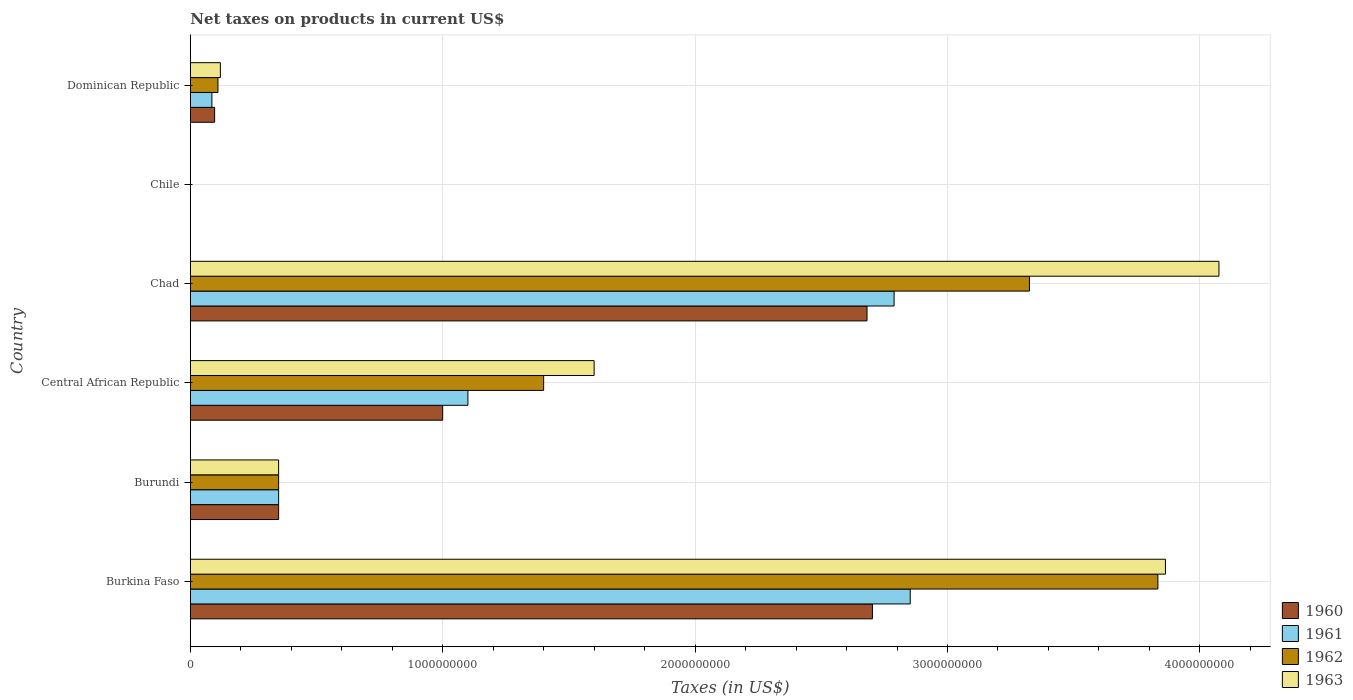How many groups of bars are there?
Keep it short and to the point. 6. Are the number of bars per tick equal to the number of legend labels?
Keep it short and to the point. Yes. How many bars are there on the 1st tick from the top?
Provide a succinct answer. 4. How many bars are there on the 6th tick from the bottom?
Make the answer very short. 4. What is the label of the 3rd group of bars from the top?
Your answer should be compact. Chad. In how many cases, is the number of bars for a given country not equal to the number of legend labels?
Make the answer very short. 0. What is the net taxes on products in 1962 in Chile?
Keep it short and to the point. 2.53e+05. Across all countries, what is the maximum net taxes on products in 1963?
Offer a terse response. 4.08e+09. Across all countries, what is the minimum net taxes on products in 1962?
Make the answer very short. 2.53e+05. In which country was the net taxes on products in 1960 maximum?
Give a very brief answer. Burkina Faso. In which country was the net taxes on products in 1963 minimum?
Offer a terse response. Chile. What is the total net taxes on products in 1962 in the graph?
Offer a very short reply. 9.02e+09. What is the difference between the net taxes on products in 1962 in Burundi and that in Central African Republic?
Your answer should be compact. -1.05e+09. What is the difference between the net taxes on products in 1961 in Chad and the net taxes on products in 1960 in Dominican Republic?
Offer a very short reply. 2.69e+09. What is the average net taxes on products in 1963 per country?
Provide a short and direct response. 1.67e+09. What is the difference between the net taxes on products in 1961 and net taxes on products in 1963 in Burkina Faso?
Ensure brevity in your answer.  -1.01e+09. What is the ratio of the net taxes on products in 1962 in Burundi to that in Central African Republic?
Keep it short and to the point. 0.25. Is the net taxes on products in 1962 in Burkina Faso less than that in Chile?
Offer a terse response. No. What is the difference between the highest and the second highest net taxes on products in 1960?
Make the answer very short. 2.13e+07. What is the difference between the highest and the lowest net taxes on products in 1962?
Offer a terse response. 3.83e+09. Is the sum of the net taxes on products in 1962 in Chad and Dominican Republic greater than the maximum net taxes on products in 1963 across all countries?
Your answer should be compact. No. What does the 1st bar from the top in Chad represents?
Your answer should be very brief. 1963. What does the 1st bar from the bottom in Central African Republic represents?
Provide a succinct answer. 1960. Is it the case that in every country, the sum of the net taxes on products in 1963 and net taxes on products in 1961 is greater than the net taxes on products in 1960?
Give a very brief answer. Yes. How many bars are there?
Make the answer very short. 24. Are all the bars in the graph horizontal?
Your answer should be very brief. Yes. How many countries are there in the graph?
Ensure brevity in your answer.  6. What is the difference between two consecutive major ticks on the X-axis?
Your answer should be very brief. 1.00e+09. Are the values on the major ticks of X-axis written in scientific E-notation?
Offer a very short reply. No. Does the graph contain grids?
Make the answer very short. Yes. Where does the legend appear in the graph?
Offer a terse response. Bottom right. How many legend labels are there?
Provide a succinct answer. 4. What is the title of the graph?
Your answer should be very brief. Net taxes on products in current US$. Does "1991" appear as one of the legend labels in the graph?
Your response must be concise. No. What is the label or title of the X-axis?
Make the answer very short. Taxes (in US$). What is the Taxes (in US$) of 1960 in Burkina Faso?
Your answer should be compact. 2.70e+09. What is the Taxes (in US$) of 1961 in Burkina Faso?
Keep it short and to the point. 2.85e+09. What is the Taxes (in US$) of 1962 in Burkina Faso?
Provide a short and direct response. 3.83e+09. What is the Taxes (in US$) in 1963 in Burkina Faso?
Provide a short and direct response. 3.86e+09. What is the Taxes (in US$) in 1960 in Burundi?
Make the answer very short. 3.50e+08. What is the Taxes (in US$) of 1961 in Burundi?
Provide a short and direct response. 3.50e+08. What is the Taxes (in US$) of 1962 in Burundi?
Your response must be concise. 3.50e+08. What is the Taxes (in US$) of 1963 in Burundi?
Your answer should be very brief. 3.50e+08. What is the Taxes (in US$) of 1960 in Central African Republic?
Provide a short and direct response. 1.00e+09. What is the Taxes (in US$) in 1961 in Central African Republic?
Provide a short and direct response. 1.10e+09. What is the Taxes (in US$) of 1962 in Central African Republic?
Your answer should be compact. 1.40e+09. What is the Taxes (in US$) in 1963 in Central African Republic?
Your response must be concise. 1.60e+09. What is the Taxes (in US$) of 1960 in Chad?
Provide a short and direct response. 2.68e+09. What is the Taxes (in US$) of 1961 in Chad?
Ensure brevity in your answer.  2.79e+09. What is the Taxes (in US$) of 1962 in Chad?
Provide a short and direct response. 3.32e+09. What is the Taxes (in US$) of 1963 in Chad?
Provide a short and direct response. 4.08e+09. What is the Taxes (in US$) in 1960 in Chile?
Provide a succinct answer. 2.02e+05. What is the Taxes (in US$) of 1961 in Chile?
Ensure brevity in your answer.  2.53e+05. What is the Taxes (in US$) in 1962 in Chile?
Offer a very short reply. 2.53e+05. What is the Taxes (in US$) of 1963 in Chile?
Your answer should be very brief. 3.54e+05. What is the Taxes (in US$) of 1960 in Dominican Republic?
Your answer should be very brief. 9.64e+07. What is the Taxes (in US$) of 1961 in Dominican Republic?
Your answer should be very brief. 8.56e+07. What is the Taxes (in US$) in 1962 in Dominican Republic?
Offer a terse response. 1.10e+08. What is the Taxes (in US$) of 1963 in Dominican Republic?
Provide a succinct answer. 1.19e+08. Across all countries, what is the maximum Taxes (in US$) of 1960?
Make the answer very short. 2.70e+09. Across all countries, what is the maximum Taxes (in US$) in 1961?
Provide a short and direct response. 2.85e+09. Across all countries, what is the maximum Taxes (in US$) in 1962?
Offer a very short reply. 3.83e+09. Across all countries, what is the maximum Taxes (in US$) of 1963?
Provide a short and direct response. 4.08e+09. Across all countries, what is the minimum Taxes (in US$) in 1960?
Your answer should be very brief. 2.02e+05. Across all countries, what is the minimum Taxes (in US$) of 1961?
Provide a succinct answer. 2.53e+05. Across all countries, what is the minimum Taxes (in US$) of 1962?
Offer a terse response. 2.53e+05. Across all countries, what is the minimum Taxes (in US$) of 1963?
Keep it short and to the point. 3.54e+05. What is the total Taxes (in US$) in 1960 in the graph?
Offer a very short reply. 6.83e+09. What is the total Taxes (in US$) in 1961 in the graph?
Offer a terse response. 7.18e+09. What is the total Taxes (in US$) in 1962 in the graph?
Provide a succinct answer. 9.02e+09. What is the total Taxes (in US$) of 1963 in the graph?
Your answer should be very brief. 1.00e+1. What is the difference between the Taxes (in US$) of 1960 in Burkina Faso and that in Burundi?
Ensure brevity in your answer.  2.35e+09. What is the difference between the Taxes (in US$) in 1961 in Burkina Faso and that in Burundi?
Keep it short and to the point. 2.50e+09. What is the difference between the Taxes (in US$) of 1962 in Burkina Faso and that in Burundi?
Your response must be concise. 3.48e+09. What is the difference between the Taxes (in US$) in 1963 in Burkina Faso and that in Burundi?
Offer a terse response. 3.51e+09. What is the difference between the Taxes (in US$) of 1960 in Burkina Faso and that in Central African Republic?
Give a very brief answer. 1.70e+09. What is the difference between the Taxes (in US$) in 1961 in Burkina Faso and that in Central African Republic?
Make the answer very short. 1.75e+09. What is the difference between the Taxes (in US$) in 1962 in Burkina Faso and that in Central African Republic?
Your answer should be compact. 2.43e+09. What is the difference between the Taxes (in US$) of 1963 in Burkina Faso and that in Central African Republic?
Keep it short and to the point. 2.26e+09. What is the difference between the Taxes (in US$) of 1960 in Burkina Faso and that in Chad?
Give a very brief answer. 2.13e+07. What is the difference between the Taxes (in US$) in 1961 in Burkina Faso and that in Chad?
Give a very brief answer. 6.39e+07. What is the difference between the Taxes (in US$) in 1962 in Burkina Faso and that in Chad?
Ensure brevity in your answer.  5.09e+08. What is the difference between the Taxes (in US$) of 1963 in Burkina Faso and that in Chad?
Offer a terse response. -2.12e+08. What is the difference between the Taxes (in US$) of 1960 in Burkina Faso and that in Chile?
Your answer should be very brief. 2.70e+09. What is the difference between the Taxes (in US$) of 1961 in Burkina Faso and that in Chile?
Provide a short and direct response. 2.85e+09. What is the difference between the Taxes (in US$) of 1962 in Burkina Faso and that in Chile?
Your response must be concise. 3.83e+09. What is the difference between the Taxes (in US$) in 1963 in Burkina Faso and that in Chile?
Offer a terse response. 3.86e+09. What is the difference between the Taxes (in US$) of 1960 in Burkina Faso and that in Dominican Republic?
Offer a terse response. 2.61e+09. What is the difference between the Taxes (in US$) of 1961 in Burkina Faso and that in Dominican Republic?
Your response must be concise. 2.77e+09. What is the difference between the Taxes (in US$) in 1962 in Burkina Faso and that in Dominican Republic?
Your answer should be compact. 3.72e+09. What is the difference between the Taxes (in US$) of 1963 in Burkina Faso and that in Dominican Republic?
Your answer should be very brief. 3.74e+09. What is the difference between the Taxes (in US$) of 1960 in Burundi and that in Central African Republic?
Your answer should be compact. -6.50e+08. What is the difference between the Taxes (in US$) of 1961 in Burundi and that in Central African Republic?
Offer a terse response. -7.50e+08. What is the difference between the Taxes (in US$) in 1962 in Burundi and that in Central African Republic?
Offer a terse response. -1.05e+09. What is the difference between the Taxes (in US$) of 1963 in Burundi and that in Central African Republic?
Offer a terse response. -1.25e+09. What is the difference between the Taxes (in US$) in 1960 in Burundi and that in Chad?
Ensure brevity in your answer.  -2.33e+09. What is the difference between the Taxes (in US$) of 1961 in Burundi and that in Chad?
Your answer should be very brief. -2.44e+09. What is the difference between the Taxes (in US$) in 1962 in Burundi and that in Chad?
Give a very brief answer. -2.97e+09. What is the difference between the Taxes (in US$) in 1963 in Burundi and that in Chad?
Provide a short and direct response. -3.73e+09. What is the difference between the Taxes (in US$) of 1960 in Burundi and that in Chile?
Provide a short and direct response. 3.50e+08. What is the difference between the Taxes (in US$) in 1961 in Burundi and that in Chile?
Offer a very short reply. 3.50e+08. What is the difference between the Taxes (in US$) of 1962 in Burundi and that in Chile?
Your answer should be compact. 3.50e+08. What is the difference between the Taxes (in US$) of 1963 in Burundi and that in Chile?
Your answer should be very brief. 3.50e+08. What is the difference between the Taxes (in US$) in 1960 in Burundi and that in Dominican Republic?
Your answer should be compact. 2.54e+08. What is the difference between the Taxes (in US$) of 1961 in Burundi and that in Dominican Republic?
Your answer should be compact. 2.64e+08. What is the difference between the Taxes (in US$) in 1962 in Burundi and that in Dominican Republic?
Keep it short and to the point. 2.40e+08. What is the difference between the Taxes (in US$) in 1963 in Burundi and that in Dominican Republic?
Offer a terse response. 2.31e+08. What is the difference between the Taxes (in US$) of 1960 in Central African Republic and that in Chad?
Your answer should be very brief. -1.68e+09. What is the difference between the Taxes (in US$) of 1961 in Central African Republic and that in Chad?
Give a very brief answer. -1.69e+09. What is the difference between the Taxes (in US$) of 1962 in Central African Republic and that in Chad?
Ensure brevity in your answer.  -1.92e+09. What is the difference between the Taxes (in US$) in 1963 in Central African Republic and that in Chad?
Keep it short and to the point. -2.48e+09. What is the difference between the Taxes (in US$) in 1960 in Central African Republic and that in Chile?
Your response must be concise. 1.00e+09. What is the difference between the Taxes (in US$) in 1961 in Central African Republic and that in Chile?
Your answer should be compact. 1.10e+09. What is the difference between the Taxes (in US$) in 1962 in Central African Republic and that in Chile?
Provide a succinct answer. 1.40e+09. What is the difference between the Taxes (in US$) in 1963 in Central African Republic and that in Chile?
Your answer should be very brief. 1.60e+09. What is the difference between the Taxes (in US$) in 1960 in Central African Republic and that in Dominican Republic?
Provide a succinct answer. 9.04e+08. What is the difference between the Taxes (in US$) of 1961 in Central African Republic and that in Dominican Republic?
Provide a short and direct response. 1.01e+09. What is the difference between the Taxes (in US$) in 1962 in Central African Republic and that in Dominican Republic?
Keep it short and to the point. 1.29e+09. What is the difference between the Taxes (in US$) in 1963 in Central African Republic and that in Dominican Republic?
Ensure brevity in your answer.  1.48e+09. What is the difference between the Taxes (in US$) of 1960 in Chad and that in Chile?
Keep it short and to the point. 2.68e+09. What is the difference between the Taxes (in US$) of 1961 in Chad and that in Chile?
Your answer should be compact. 2.79e+09. What is the difference between the Taxes (in US$) in 1962 in Chad and that in Chile?
Your response must be concise. 3.32e+09. What is the difference between the Taxes (in US$) of 1963 in Chad and that in Chile?
Provide a short and direct response. 4.08e+09. What is the difference between the Taxes (in US$) in 1960 in Chad and that in Dominican Republic?
Offer a very short reply. 2.58e+09. What is the difference between the Taxes (in US$) in 1961 in Chad and that in Dominican Republic?
Offer a very short reply. 2.70e+09. What is the difference between the Taxes (in US$) of 1962 in Chad and that in Dominican Republic?
Provide a succinct answer. 3.22e+09. What is the difference between the Taxes (in US$) of 1963 in Chad and that in Dominican Republic?
Your answer should be compact. 3.96e+09. What is the difference between the Taxes (in US$) of 1960 in Chile and that in Dominican Republic?
Keep it short and to the point. -9.62e+07. What is the difference between the Taxes (in US$) in 1961 in Chile and that in Dominican Republic?
Provide a succinct answer. -8.53e+07. What is the difference between the Taxes (in US$) in 1962 in Chile and that in Dominican Republic?
Your answer should be very brief. -1.09e+08. What is the difference between the Taxes (in US$) of 1963 in Chile and that in Dominican Republic?
Offer a terse response. -1.19e+08. What is the difference between the Taxes (in US$) of 1960 in Burkina Faso and the Taxes (in US$) of 1961 in Burundi?
Provide a succinct answer. 2.35e+09. What is the difference between the Taxes (in US$) of 1960 in Burkina Faso and the Taxes (in US$) of 1962 in Burundi?
Provide a succinct answer. 2.35e+09. What is the difference between the Taxes (in US$) in 1960 in Burkina Faso and the Taxes (in US$) in 1963 in Burundi?
Keep it short and to the point. 2.35e+09. What is the difference between the Taxes (in US$) of 1961 in Burkina Faso and the Taxes (in US$) of 1962 in Burundi?
Offer a terse response. 2.50e+09. What is the difference between the Taxes (in US$) in 1961 in Burkina Faso and the Taxes (in US$) in 1963 in Burundi?
Your answer should be very brief. 2.50e+09. What is the difference between the Taxes (in US$) in 1962 in Burkina Faso and the Taxes (in US$) in 1963 in Burundi?
Ensure brevity in your answer.  3.48e+09. What is the difference between the Taxes (in US$) in 1960 in Burkina Faso and the Taxes (in US$) in 1961 in Central African Republic?
Your response must be concise. 1.60e+09. What is the difference between the Taxes (in US$) in 1960 in Burkina Faso and the Taxes (in US$) in 1962 in Central African Republic?
Your answer should be compact. 1.30e+09. What is the difference between the Taxes (in US$) in 1960 in Burkina Faso and the Taxes (in US$) in 1963 in Central African Republic?
Your response must be concise. 1.10e+09. What is the difference between the Taxes (in US$) of 1961 in Burkina Faso and the Taxes (in US$) of 1962 in Central African Republic?
Your response must be concise. 1.45e+09. What is the difference between the Taxes (in US$) of 1961 in Burkina Faso and the Taxes (in US$) of 1963 in Central African Republic?
Ensure brevity in your answer.  1.25e+09. What is the difference between the Taxes (in US$) of 1962 in Burkina Faso and the Taxes (in US$) of 1963 in Central African Republic?
Make the answer very short. 2.23e+09. What is the difference between the Taxes (in US$) of 1960 in Burkina Faso and the Taxes (in US$) of 1961 in Chad?
Your response must be concise. -8.59e+07. What is the difference between the Taxes (in US$) of 1960 in Burkina Faso and the Taxes (in US$) of 1962 in Chad?
Your response must be concise. -6.22e+08. What is the difference between the Taxes (in US$) of 1960 in Burkina Faso and the Taxes (in US$) of 1963 in Chad?
Keep it short and to the point. -1.37e+09. What is the difference between the Taxes (in US$) of 1961 in Burkina Faso and the Taxes (in US$) of 1962 in Chad?
Keep it short and to the point. -4.72e+08. What is the difference between the Taxes (in US$) in 1961 in Burkina Faso and the Taxes (in US$) in 1963 in Chad?
Make the answer very short. -1.22e+09. What is the difference between the Taxes (in US$) in 1962 in Burkina Faso and the Taxes (in US$) in 1963 in Chad?
Keep it short and to the point. -2.42e+08. What is the difference between the Taxes (in US$) of 1960 in Burkina Faso and the Taxes (in US$) of 1961 in Chile?
Your answer should be compact. 2.70e+09. What is the difference between the Taxes (in US$) of 1960 in Burkina Faso and the Taxes (in US$) of 1962 in Chile?
Provide a succinct answer. 2.70e+09. What is the difference between the Taxes (in US$) in 1960 in Burkina Faso and the Taxes (in US$) in 1963 in Chile?
Keep it short and to the point. 2.70e+09. What is the difference between the Taxes (in US$) of 1961 in Burkina Faso and the Taxes (in US$) of 1962 in Chile?
Provide a succinct answer. 2.85e+09. What is the difference between the Taxes (in US$) in 1961 in Burkina Faso and the Taxes (in US$) in 1963 in Chile?
Give a very brief answer. 2.85e+09. What is the difference between the Taxes (in US$) in 1962 in Burkina Faso and the Taxes (in US$) in 1963 in Chile?
Your response must be concise. 3.83e+09. What is the difference between the Taxes (in US$) in 1960 in Burkina Faso and the Taxes (in US$) in 1961 in Dominican Republic?
Ensure brevity in your answer.  2.62e+09. What is the difference between the Taxes (in US$) in 1960 in Burkina Faso and the Taxes (in US$) in 1962 in Dominican Republic?
Keep it short and to the point. 2.59e+09. What is the difference between the Taxes (in US$) of 1960 in Burkina Faso and the Taxes (in US$) of 1963 in Dominican Republic?
Your answer should be compact. 2.58e+09. What is the difference between the Taxes (in US$) of 1961 in Burkina Faso and the Taxes (in US$) of 1962 in Dominican Republic?
Offer a very short reply. 2.74e+09. What is the difference between the Taxes (in US$) of 1961 in Burkina Faso and the Taxes (in US$) of 1963 in Dominican Republic?
Your answer should be compact. 2.73e+09. What is the difference between the Taxes (in US$) in 1962 in Burkina Faso and the Taxes (in US$) in 1963 in Dominican Republic?
Provide a short and direct response. 3.71e+09. What is the difference between the Taxes (in US$) of 1960 in Burundi and the Taxes (in US$) of 1961 in Central African Republic?
Make the answer very short. -7.50e+08. What is the difference between the Taxes (in US$) in 1960 in Burundi and the Taxes (in US$) in 1962 in Central African Republic?
Ensure brevity in your answer.  -1.05e+09. What is the difference between the Taxes (in US$) of 1960 in Burundi and the Taxes (in US$) of 1963 in Central African Republic?
Your response must be concise. -1.25e+09. What is the difference between the Taxes (in US$) of 1961 in Burundi and the Taxes (in US$) of 1962 in Central African Republic?
Offer a very short reply. -1.05e+09. What is the difference between the Taxes (in US$) in 1961 in Burundi and the Taxes (in US$) in 1963 in Central African Republic?
Your answer should be very brief. -1.25e+09. What is the difference between the Taxes (in US$) in 1962 in Burundi and the Taxes (in US$) in 1963 in Central African Republic?
Your answer should be very brief. -1.25e+09. What is the difference between the Taxes (in US$) of 1960 in Burundi and the Taxes (in US$) of 1961 in Chad?
Give a very brief answer. -2.44e+09. What is the difference between the Taxes (in US$) in 1960 in Burundi and the Taxes (in US$) in 1962 in Chad?
Offer a very short reply. -2.97e+09. What is the difference between the Taxes (in US$) of 1960 in Burundi and the Taxes (in US$) of 1963 in Chad?
Make the answer very short. -3.73e+09. What is the difference between the Taxes (in US$) of 1961 in Burundi and the Taxes (in US$) of 1962 in Chad?
Ensure brevity in your answer.  -2.97e+09. What is the difference between the Taxes (in US$) of 1961 in Burundi and the Taxes (in US$) of 1963 in Chad?
Keep it short and to the point. -3.73e+09. What is the difference between the Taxes (in US$) in 1962 in Burundi and the Taxes (in US$) in 1963 in Chad?
Offer a terse response. -3.73e+09. What is the difference between the Taxes (in US$) in 1960 in Burundi and the Taxes (in US$) in 1961 in Chile?
Your answer should be very brief. 3.50e+08. What is the difference between the Taxes (in US$) of 1960 in Burundi and the Taxes (in US$) of 1962 in Chile?
Ensure brevity in your answer.  3.50e+08. What is the difference between the Taxes (in US$) in 1960 in Burundi and the Taxes (in US$) in 1963 in Chile?
Give a very brief answer. 3.50e+08. What is the difference between the Taxes (in US$) of 1961 in Burundi and the Taxes (in US$) of 1962 in Chile?
Offer a terse response. 3.50e+08. What is the difference between the Taxes (in US$) of 1961 in Burundi and the Taxes (in US$) of 1963 in Chile?
Offer a terse response. 3.50e+08. What is the difference between the Taxes (in US$) of 1962 in Burundi and the Taxes (in US$) of 1963 in Chile?
Give a very brief answer. 3.50e+08. What is the difference between the Taxes (in US$) in 1960 in Burundi and the Taxes (in US$) in 1961 in Dominican Republic?
Offer a very short reply. 2.64e+08. What is the difference between the Taxes (in US$) in 1960 in Burundi and the Taxes (in US$) in 1962 in Dominican Republic?
Keep it short and to the point. 2.40e+08. What is the difference between the Taxes (in US$) in 1960 in Burundi and the Taxes (in US$) in 1963 in Dominican Republic?
Provide a succinct answer. 2.31e+08. What is the difference between the Taxes (in US$) in 1961 in Burundi and the Taxes (in US$) in 1962 in Dominican Republic?
Offer a very short reply. 2.40e+08. What is the difference between the Taxes (in US$) in 1961 in Burundi and the Taxes (in US$) in 1963 in Dominican Republic?
Ensure brevity in your answer.  2.31e+08. What is the difference between the Taxes (in US$) of 1962 in Burundi and the Taxes (in US$) of 1963 in Dominican Republic?
Provide a succinct answer. 2.31e+08. What is the difference between the Taxes (in US$) in 1960 in Central African Republic and the Taxes (in US$) in 1961 in Chad?
Your answer should be compact. -1.79e+09. What is the difference between the Taxes (in US$) of 1960 in Central African Republic and the Taxes (in US$) of 1962 in Chad?
Provide a short and direct response. -2.32e+09. What is the difference between the Taxes (in US$) of 1960 in Central African Republic and the Taxes (in US$) of 1963 in Chad?
Offer a terse response. -3.08e+09. What is the difference between the Taxes (in US$) of 1961 in Central African Republic and the Taxes (in US$) of 1962 in Chad?
Give a very brief answer. -2.22e+09. What is the difference between the Taxes (in US$) of 1961 in Central African Republic and the Taxes (in US$) of 1963 in Chad?
Provide a short and direct response. -2.98e+09. What is the difference between the Taxes (in US$) in 1962 in Central African Republic and the Taxes (in US$) in 1963 in Chad?
Your answer should be compact. -2.68e+09. What is the difference between the Taxes (in US$) of 1960 in Central African Republic and the Taxes (in US$) of 1961 in Chile?
Your response must be concise. 1.00e+09. What is the difference between the Taxes (in US$) in 1960 in Central African Republic and the Taxes (in US$) in 1962 in Chile?
Offer a very short reply. 1.00e+09. What is the difference between the Taxes (in US$) in 1960 in Central African Republic and the Taxes (in US$) in 1963 in Chile?
Keep it short and to the point. 1.00e+09. What is the difference between the Taxes (in US$) in 1961 in Central African Republic and the Taxes (in US$) in 1962 in Chile?
Keep it short and to the point. 1.10e+09. What is the difference between the Taxes (in US$) in 1961 in Central African Republic and the Taxes (in US$) in 1963 in Chile?
Give a very brief answer. 1.10e+09. What is the difference between the Taxes (in US$) in 1962 in Central African Republic and the Taxes (in US$) in 1963 in Chile?
Keep it short and to the point. 1.40e+09. What is the difference between the Taxes (in US$) of 1960 in Central African Republic and the Taxes (in US$) of 1961 in Dominican Republic?
Your answer should be very brief. 9.14e+08. What is the difference between the Taxes (in US$) of 1960 in Central African Republic and the Taxes (in US$) of 1962 in Dominican Republic?
Your answer should be compact. 8.90e+08. What is the difference between the Taxes (in US$) of 1960 in Central African Republic and the Taxes (in US$) of 1963 in Dominican Republic?
Make the answer very short. 8.81e+08. What is the difference between the Taxes (in US$) in 1961 in Central African Republic and the Taxes (in US$) in 1962 in Dominican Republic?
Your answer should be compact. 9.90e+08. What is the difference between the Taxes (in US$) in 1961 in Central African Republic and the Taxes (in US$) in 1963 in Dominican Republic?
Provide a succinct answer. 9.81e+08. What is the difference between the Taxes (in US$) of 1962 in Central African Republic and the Taxes (in US$) of 1963 in Dominican Republic?
Keep it short and to the point. 1.28e+09. What is the difference between the Taxes (in US$) of 1960 in Chad and the Taxes (in US$) of 1961 in Chile?
Offer a very short reply. 2.68e+09. What is the difference between the Taxes (in US$) in 1960 in Chad and the Taxes (in US$) in 1962 in Chile?
Offer a terse response. 2.68e+09. What is the difference between the Taxes (in US$) in 1960 in Chad and the Taxes (in US$) in 1963 in Chile?
Keep it short and to the point. 2.68e+09. What is the difference between the Taxes (in US$) in 1961 in Chad and the Taxes (in US$) in 1962 in Chile?
Your response must be concise. 2.79e+09. What is the difference between the Taxes (in US$) of 1961 in Chad and the Taxes (in US$) of 1963 in Chile?
Offer a terse response. 2.79e+09. What is the difference between the Taxes (in US$) in 1962 in Chad and the Taxes (in US$) in 1963 in Chile?
Provide a succinct answer. 3.32e+09. What is the difference between the Taxes (in US$) in 1960 in Chad and the Taxes (in US$) in 1961 in Dominican Republic?
Provide a succinct answer. 2.60e+09. What is the difference between the Taxes (in US$) of 1960 in Chad and the Taxes (in US$) of 1962 in Dominican Republic?
Make the answer very short. 2.57e+09. What is the difference between the Taxes (in US$) of 1960 in Chad and the Taxes (in US$) of 1963 in Dominican Republic?
Give a very brief answer. 2.56e+09. What is the difference between the Taxes (in US$) in 1961 in Chad and the Taxes (in US$) in 1962 in Dominican Republic?
Make the answer very short. 2.68e+09. What is the difference between the Taxes (in US$) of 1961 in Chad and the Taxes (in US$) of 1963 in Dominican Republic?
Provide a succinct answer. 2.67e+09. What is the difference between the Taxes (in US$) in 1962 in Chad and the Taxes (in US$) in 1963 in Dominican Republic?
Ensure brevity in your answer.  3.21e+09. What is the difference between the Taxes (in US$) of 1960 in Chile and the Taxes (in US$) of 1961 in Dominican Republic?
Ensure brevity in your answer.  -8.54e+07. What is the difference between the Taxes (in US$) of 1960 in Chile and the Taxes (in US$) of 1962 in Dominican Republic?
Give a very brief answer. -1.09e+08. What is the difference between the Taxes (in US$) in 1960 in Chile and the Taxes (in US$) in 1963 in Dominican Republic?
Your response must be concise. -1.19e+08. What is the difference between the Taxes (in US$) in 1961 in Chile and the Taxes (in US$) in 1962 in Dominican Republic?
Your answer should be very brief. -1.09e+08. What is the difference between the Taxes (in US$) in 1961 in Chile and the Taxes (in US$) in 1963 in Dominican Republic?
Offer a terse response. -1.19e+08. What is the difference between the Taxes (in US$) in 1962 in Chile and the Taxes (in US$) in 1963 in Dominican Republic?
Make the answer very short. -1.19e+08. What is the average Taxes (in US$) of 1960 per country?
Ensure brevity in your answer.  1.14e+09. What is the average Taxes (in US$) in 1961 per country?
Give a very brief answer. 1.20e+09. What is the average Taxes (in US$) in 1962 per country?
Offer a very short reply. 1.50e+09. What is the average Taxes (in US$) in 1963 per country?
Provide a succinct answer. 1.67e+09. What is the difference between the Taxes (in US$) of 1960 and Taxes (in US$) of 1961 in Burkina Faso?
Offer a very short reply. -1.50e+08. What is the difference between the Taxes (in US$) of 1960 and Taxes (in US$) of 1962 in Burkina Faso?
Your answer should be compact. -1.13e+09. What is the difference between the Taxes (in US$) of 1960 and Taxes (in US$) of 1963 in Burkina Faso?
Offer a terse response. -1.16e+09. What is the difference between the Taxes (in US$) of 1961 and Taxes (in US$) of 1962 in Burkina Faso?
Keep it short and to the point. -9.81e+08. What is the difference between the Taxes (in US$) of 1961 and Taxes (in US$) of 1963 in Burkina Faso?
Offer a terse response. -1.01e+09. What is the difference between the Taxes (in US$) in 1962 and Taxes (in US$) in 1963 in Burkina Faso?
Your answer should be compact. -3.00e+07. What is the difference between the Taxes (in US$) of 1960 and Taxes (in US$) of 1961 in Burundi?
Give a very brief answer. 0. What is the difference between the Taxes (in US$) of 1960 and Taxes (in US$) of 1962 in Burundi?
Your answer should be very brief. 0. What is the difference between the Taxes (in US$) of 1960 and Taxes (in US$) of 1963 in Burundi?
Your answer should be very brief. 0. What is the difference between the Taxes (in US$) in 1962 and Taxes (in US$) in 1963 in Burundi?
Give a very brief answer. 0. What is the difference between the Taxes (in US$) in 1960 and Taxes (in US$) in 1961 in Central African Republic?
Give a very brief answer. -1.00e+08. What is the difference between the Taxes (in US$) in 1960 and Taxes (in US$) in 1962 in Central African Republic?
Provide a succinct answer. -4.00e+08. What is the difference between the Taxes (in US$) in 1960 and Taxes (in US$) in 1963 in Central African Republic?
Your answer should be compact. -6.00e+08. What is the difference between the Taxes (in US$) of 1961 and Taxes (in US$) of 1962 in Central African Republic?
Provide a short and direct response. -3.00e+08. What is the difference between the Taxes (in US$) in 1961 and Taxes (in US$) in 1963 in Central African Republic?
Offer a very short reply. -5.00e+08. What is the difference between the Taxes (in US$) of 1962 and Taxes (in US$) of 1963 in Central African Republic?
Your response must be concise. -2.00e+08. What is the difference between the Taxes (in US$) in 1960 and Taxes (in US$) in 1961 in Chad?
Offer a very short reply. -1.07e+08. What is the difference between the Taxes (in US$) in 1960 and Taxes (in US$) in 1962 in Chad?
Make the answer very short. -6.44e+08. What is the difference between the Taxes (in US$) in 1960 and Taxes (in US$) in 1963 in Chad?
Your answer should be very brief. -1.39e+09. What is the difference between the Taxes (in US$) in 1961 and Taxes (in US$) in 1962 in Chad?
Your answer should be very brief. -5.36e+08. What is the difference between the Taxes (in US$) in 1961 and Taxes (in US$) in 1963 in Chad?
Provide a short and direct response. -1.29e+09. What is the difference between the Taxes (in US$) of 1962 and Taxes (in US$) of 1963 in Chad?
Keep it short and to the point. -7.51e+08. What is the difference between the Taxes (in US$) of 1960 and Taxes (in US$) of 1961 in Chile?
Offer a terse response. -5.06e+04. What is the difference between the Taxes (in US$) in 1960 and Taxes (in US$) in 1962 in Chile?
Keep it short and to the point. -5.06e+04. What is the difference between the Taxes (in US$) of 1960 and Taxes (in US$) of 1963 in Chile?
Your answer should be very brief. -1.52e+05. What is the difference between the Taxes (in US$) in 1961 and Taxes (in US$) in 1962 in Chile?
Your answer should be compact. 0. What is the difference between the Taxes (in US$) in 1961 and Taxes (in US$) in 1963 in Chile?
Your answer should be very brief. -1.01e+05. What is the difference between the Taxes (in US$) of 1962 and Taxes (in US$) of 1963 in Chile?
Your response must be concise. -1.01e+05. What is the difference between the Taxes (in US$) in 1960 and Taxes (in US$) in 1961 in Dominican Republic?
Keep it short and to the point. 1.08e+07. What is the difference between the Taxes (in US$) in 1960 and Taxes (in US$) in 1962 in Dominican Republic?
Your answer should be very brief. -1.32e+07. What is the difference between the Taxes (in US$) of 1960 and Taxes (in US$) of 1963 in Dominican Republic?
Provide a short and direct response. -2.28e+07. What is the difference between the Taxes (in US$) of 1961 and Taxes (in US$) of 1962 in Dominican Republic?
Ensure brevity in your answer.  -2.40e+07. What is the difference between the Taxes (in US$) of 1961 and Taxes (in US$) of 1963 in Dominican Republic?
Your answer should be compact. -3.36e+07. What is the difference between the Taxes (in US$) of 1962 and Taxes (in US$) of 1963 in Dominican Republic?
Your response must be concise. -9.60e+06. What is the ratio of the Taxes (in US$) in 1960 in Burkina Faso to that in Burundi?
Provide a short and direct response. 7.72. What is the ratio of the Taxes (in US$) in 1961 in Burkina Faso to that in Burundi?
Keep it short and to the point. 8.15. What is the ratio of the Taxes (in US$) in 1962 in Burkina Faso to that in Burundi?
Offer a terse response. 10.95. What is the ratio of the Taxes (in US$) of 1963 in Burkina Faso to that in Burundi?
Offer a terse response. 11.04. What is the ratio of the Taxes (in US$) of 1960 in Burkina Faso to that in Central African Republic?
Ensure brevity in your answer.  2.7. What is the ratio of the Taxes (in US$) in 1961 in Burkina Faso to that in Central African Republic?
Ensure brevity in your answer.  2.59. What is the ratio of the Taxes (in US$) of 1962 in Burkina Faso to that in Central African Republic?
Provide a short and direct response. 2.74. What is the ratio of the Taxes (in US$) in 1963 in Burkina Faso to that in Central African Republic?
Provide a short and direct response. 2.41. What is the ratio of the Taxes (in US$) in 1960 in Burkina Faso to that in Chad?
Your answer should be compact. 1.01. What is the ratio of the Taxes (in US$) in 1961 in Burkina Faso to that in Chad?
Make the answer very short. 1.02. What is the ratio of the Taxes (in US$) of 1962 in Burkina Faso to that in Chad?
Ensure brevity in your answer.  1.15. What is the ratio of the Taxes (in US$) of 1963 in Burkina Faso to that in Chad?
Offer a terse response. 0.95. What is the ratio of the Taxes (in US$) of 1960 in Burkina Faso to that in Chile?
Offer a very short reply. 1.33e+04. What is the ratio of the Taxes (in US$) of 1961 in Burkina Faso to that in Chile?
Your answer should be very brief. 1.13e+04. What is the ratio of the Taxes (in US$) of 1962 in Burkina Faso to that in Chile?
Make the answer very short. 1.51e+04. What is the ratio of the Taxes (in US$) of 1963 in Burkina Faso to that in Chile?
Provide a short and direct response. 1.09e+04. What is the ratio of the Taxes (in US$) in 1960 in Burkina Faso to that in Dominican Republic?
Give a very brief answer. 28.04. What is the ratio of the Taxes (in US$) in 1961 in Burkina Faso to that in Dominican Republic?
Make the answer very short. 33.32. What is the ratio of the Taxes (in US$) in 1962 in Burkina Faso to that in Dominican Republic?
Your response must be concise. 34.98. What is the ratio of the Taxes (in US$) of 1963 in Burkina Faso to that in Dominican Republic?
Offer a terse response. 32.41. What is the ratio of the Taxes (in US$) in 1960 in Burundi to that in Central African Republic?
Offer a very short reply. 0.35. What is the ratio of the Taxes (in US$) in 1961 in Burundi to that in Central African Republic?
Keep it short and to the point. 0.32. What is the ratio of the Taxes (in US$) in 1962 in Burundi to that in Central African Republic?
Your response must be concise. 0.25. What is the ratio of the Taxes (in US$) in 1963 in Burundi to that in Central African Republic?
Your answer should be compact. 0.22. What is the ratio of the Taxes (in US$) of 1960 in Burundi to that in Chad?
Your response must be concise. 0.13. What is the ratio of the Taxes (in US$) in 1961 in Burundi to that in Chad?
Provide a succinct answer. 0.13. What is the ratio of the Taxes (in US$) of 1962 in Burundi to that in Chad?
Offer a very short reply. 0.11. What is the ratio of the Taxes (in US$) of 1963 in Burundi to that in Chad?
Offer a terse response. 0.09. What is the ratio of the Taxes (in US$) in 1960 in Burundi to that in Chile?
Provide a succinct answer. 1728.4. What is the ratio of the Taxes (in US$) of 1961 in Burundi to that in Chile?
Provide a short and direct response. 1382.85. What is the ratio of the Taxes (in US$) in 1962 in Burundi to that in Chile?
Offer a terse response. 1382.85. What is the ratio of the Taxes (in US$) of 1963 in Burundi to that in Chile?
Provide a short and direct response. 987.58. What is the ratio of the Taxes (in US$) in 1960 in Burundi to that in Dominican Republic?
Offer a very short reply. 3.63. What is the ratio of the Taxes (in US$) of 1961 in Burundi to that in Dominican Republic?
Your answer should be compact. 4.09. What is the ratio of the Taxes (in US$) of 1962 in Burundi to that in Dominican Republic?
Make the answer very short. 3.19. What is the ratio of the Taxes (in US$) of 1963 in Burundi to that in Dominican Republic?
Provide a short and direct response. 2.94. What is the ratio of the Taxes (in US$) in 1960 in Central African Republic to that in Chad?
Provide a short and direct response. 0.37. What is the ratio of the Taxes (in US$) of 1961 in Central African Republic to that in Chad?
Provide a short and direct response. 0.39. What is the ratio of the Taxes (in US$) in 1962 in Central African Republic to that in Chad?
Offer a terse response. 0.42. What is the ratio of the Taxes (in US$) in 1963 in Central African Republic to that in Chad?
Make the answer very short. 0.39. What is the ratio of the Taxes (in US$) of 1960 in Central African Republic to that in Chile?
Your answer should be very brief. 4938.27. What is the ratio of the Taxes (in US$) of 1961 in Central African Republic to that in Chile?
Offer a very short reply. 4346.11. What is the ratio of the Taxes (in US$) of 1962 in Central African Republic to that in Chile?
Your answer should be compact. 5531.41. What is the ratio of the Taxes (in US$) of 1963 in Central African Republic to that in Chile?
Provide a short and direct response. 4514.67. What is the ratio of the Taxes (in US$) in 1960 in Central African Republic to that in Dominican Republic?
Your answer should be compact. 10.37. What is the ratio of the Taxes (in US$) in 1961 in Central African Republic to that in Dominican Republic?
Keep it short and to the point. 12.85. What is the ratio of the Taxes (in US$) in 1962 in Central African Republic to that in Dominican Republic?
Ensure brevity in your answer.  12.77. What is the ratio of the Taxes (in US$) in 1963 in Central African Republic to that in Dominican Republic?
Give a very brief answer. 13.42. What is the ratio of the Taxes (in US$) of 1960 in Chad to that in Chile?
Keep it short and to the point. 1.32e+04. What is the ratio of the Taxes (in US$) of 1961 in Chad to that in Chile?
Ensure brevity in your answer.  1.10e+04. What is the ratio of the Taxes (in US$) of 1962 in Chad to that in Chile?
Ensure brevity in your answer.  1.31e+04. What is the ratio of the Taxes (in US$) of 1963 in Chad to that in Chile?
Make the answer very short. 1.15e+04. What is the ratio of the Taxes (in US$) in 1960 in Chad to that in Dominican Republic?
Provide a succinct answer. 27.81. What is the ratio of the Taxes (in US$) in 1961 in Chad to that in Dominican Republic?
Ensure brevity in your answer.  32.58. What is the ratio of the Taxes (in US$) in 1962 in Chad to that in Dominican Republic?
Ensure brevity in your answer.  30.34. What is the ratio of the Taxes (in US$) of 1963 in Chad to that in Dominican Republic?
Offer a terse response. 34.19. What is the ratio of the Taxes (in US$) in 1960 in Chile to that in Dominican Republic?
Your answer should be very brief. 0. What is the ratio of the Taxes (in US$) in 1961 in Chile to that in Dominican Republic?
Offer a terse response. 0. What is the ratio of the Taxes (in US$) in 1962 in Chile to that in Dominican Republic?
Your answer should be compact. 0. What is the ratio of the Taxes (in US$) in 1963 in Chile to that in Dominican Republic?
Your response must be concise. 0. What is the difference between the highest and the second highest Taxes (in US$) in 1960?
Give a very brief answer. 2.13e+07. What is the difference between the highest and the second highest Taxes (in US$) of 1961?
Your response must be concise. 6.39e+07. What is the difference between the highest and the second highest Taxes (in US$) of 1962?
Provide a succinct answer. 5.09e+08. What is the difference between the highest and the second highest Taxes (in US$) of 1963?
Provide a succinct answer. 2.12e+08. What is the difference between the highest and the lowest Taxes (in US$) of 1960?
Your response must be concise. 2.70e+09. What is the difference between the highest and the lowest Taxes (in US$) of 1961?
Keep it short and to the point. 2.85e+09. What is the difference between the highest and the lowest Taxes (in US$) of 1962?
Offer a very short reply. 3.83e+09. What is the difference between the highest and the lowest Taxes (in US$) of 1963?
Offer a terse response. 4.08e+09. 